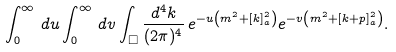Convert formula to latex. <formula><loc_0><loc_0><loc_500><loc_500>\int _ { 0 } ^ { \infty } \, d u \int _ { 0 } ^ { \infty } \, d v \int _ { \Box } \frac { d ^ { 4 } k } { ( 2 \pi ) ^ { 4 } } \, e ^ { - u \left ( m ^ { 2 } + [ k ] _ { a } ^ { 2 } \right ) } e ^ { - v \left ( m ^ { 2 } + [ k + p ] _ { a } ^ { 2 } \right ) } .</formula> 